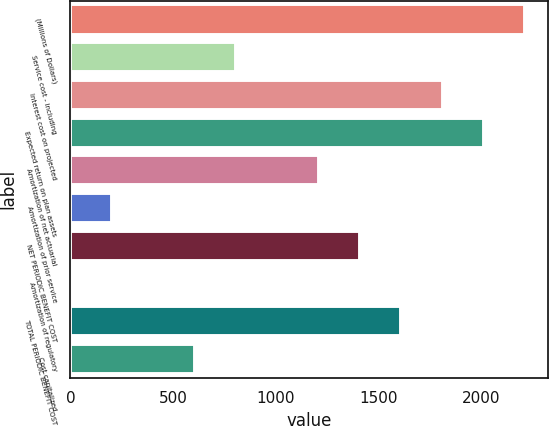<chart> <loc_0><loc_0><loc_500><loc_500><bar_chart><fcel>(Millions of Dollars)<fcel>Service cost - including<fcel>Interest cost on projected<fcel>Expected return on plan assets<fcel>Amortization of net actuarial<fcel>Amortization of prior service<fcel>NET PERIODIC BENEFIT COST<fcel>Amortization of regulatory<fcel>TOTAL PERIODIC BENEFIT COST<fcel>Cost capitalized<nl><fcel>2211.9<fcel>805.6<fcel>1810.1<fcel>2011<fcel>1207.4<fcel>202.9<fcel>1408.3<fcel>2<fcel>1609.2<fcel>604.7<nl></chart> 